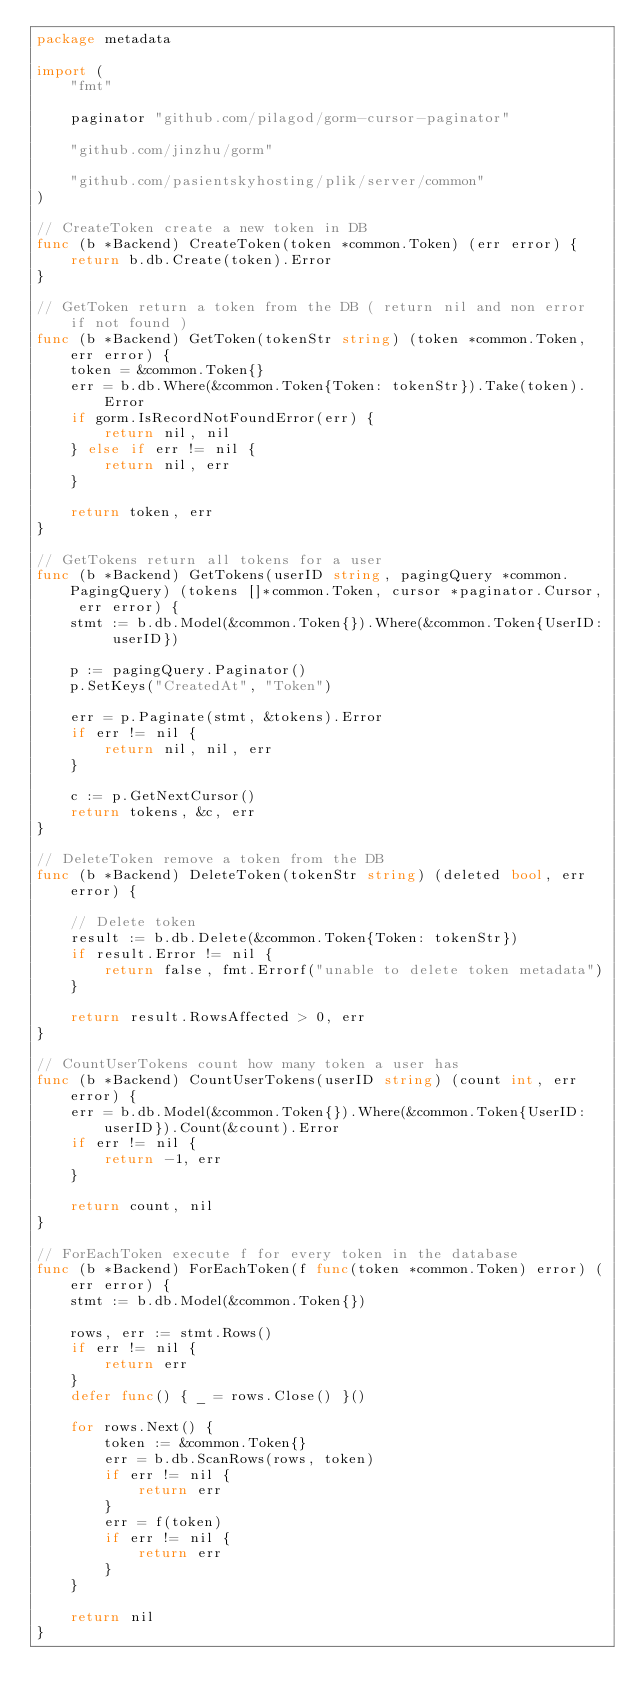<code> <loc_0><loc_0><loc_500><loc_500><_Go_>package metadata

import (
	"fmt"

	paginator "github.com/pilagod/gorm-cursor-paginator"

	"github.com/jinzhu/gorm"

	"github.com/pasientskyhosting/plik/server/common"
)

// CreateToken create a new token in DB
func (b *Backend) CreateToken(token *common.Token) (err error) {
	return b.db.Create(token).Error
}

// GetToken return a token from the DB ( return nil and non error if not found )
func (b *Backend) GetToken(tokenStr string) (token *common.Token, err error) {
	token = &common.Token{}
	err = b.db.Where(&common.Token{Token: tokenStr}).Take(token).Error
	if gorm.IsRecordNotFoundError(err) {
		return nil, nil
	} else if err != nil {
		return nil, err
	}

	return token, err
}

// GetTokens return all tokens for a user
func (b *Backend) GetTokens(userID string, pagingQuery *common.PagingQuery) (tokens []*common.Token, cursor *paginator.Cursor, err error) {
	stmt := b.db.Model(&common.Token{}).Where(&common.Token{UserID: userID})

	p := pagingQuery.Paginator()
	p.SetKeys("CreatedAt", "Token")

	err = p.Paginate(stmt, &tokens).Error
	if err != nil {
		return nil, nil, err
	}

	c := p.GetNextCursor()
	return tokens, &c, err
}

// DeleteToken remove a token from the DB
func (b *Backend) DeleteToken(tokenStr string) (deleted bool, err error) {

	// Delete token
	result := b.db.Delete(&common.Token{Token: tokenStr})
	if result.Error != nil {
		return false, fmt.Errorf("unable to delete token metadata")
	}

	return result.RowsAffected > 0, err
}

// CountUserTokens count how many token a user has
func (b *Backend) CountUserTokens(userID string) (count int, err error) {
	err = b.db.Model(&common.Token{}).Where(&common.Token{UserID: userID}).Count(&count).Error
	if err != nil {
		return -1, err
	}

	return count, nil
}

// ForEachToken execute f for every token in the database
func (b *Backend) ForEachToken(f func(token *common.Token) error) (err error) {
	stmt := b.db.Model(&common.Token{})

	rows, err := stmt.Rows()
	if err != nil {
		return err
	}
	defer func() { _ = rows.Close() }()

	for rows.Next() {
		token := &common.Token{}
		err = b.db.ScanRows(rows, token)
		if err != nil {
			return err
		}
		err = f(token)
		if err != nil {
			return err
		}
	}

	return nil
}
</code> 